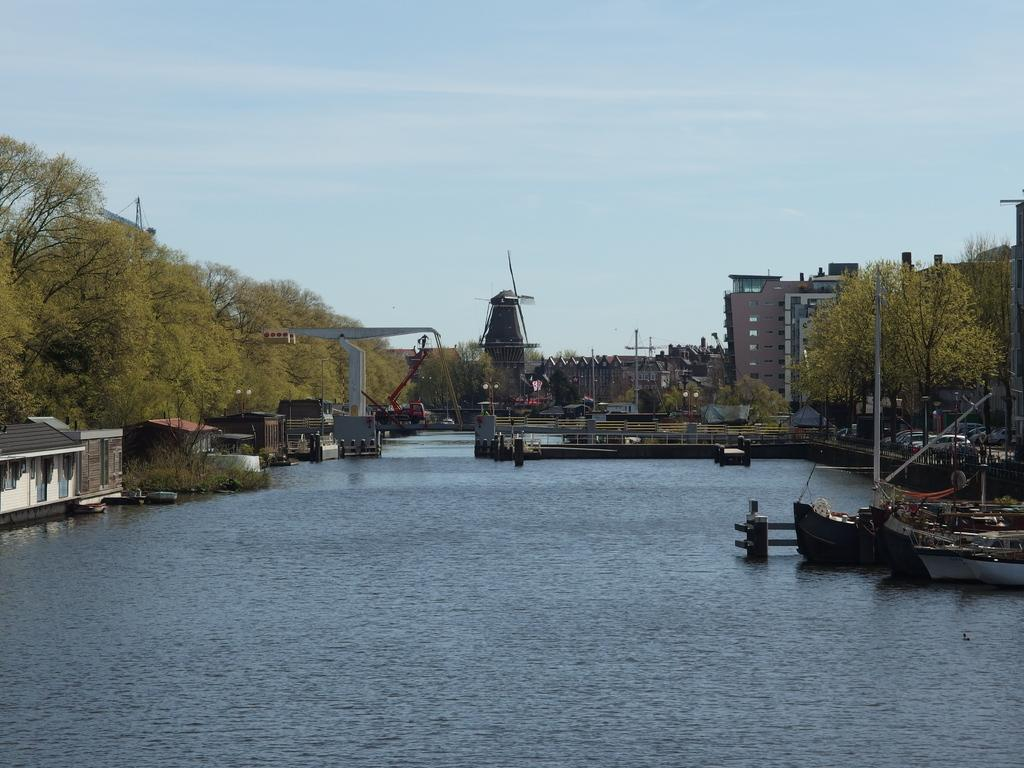What is positioned above the water in the image? There are boats above the water in the image. What type of vegetation can be seen in the image? There are plants and trees visible in the image. What type of structures are present in the image? There are houses, buildings, and a bridge in the image. What are the poles used for in the image? The poles in the image are likely used for supporting wires or other infrastructure. What is visible in the background of the image? There are buildings, poles, and the sky visible in the background of the image. What type of twig is being used as a lunchroom table in the image? There is no twig or lunchroom table present in the image. How does the ice affect the boats in the image? There is no ice present in the image, so it does not affect the boats. 